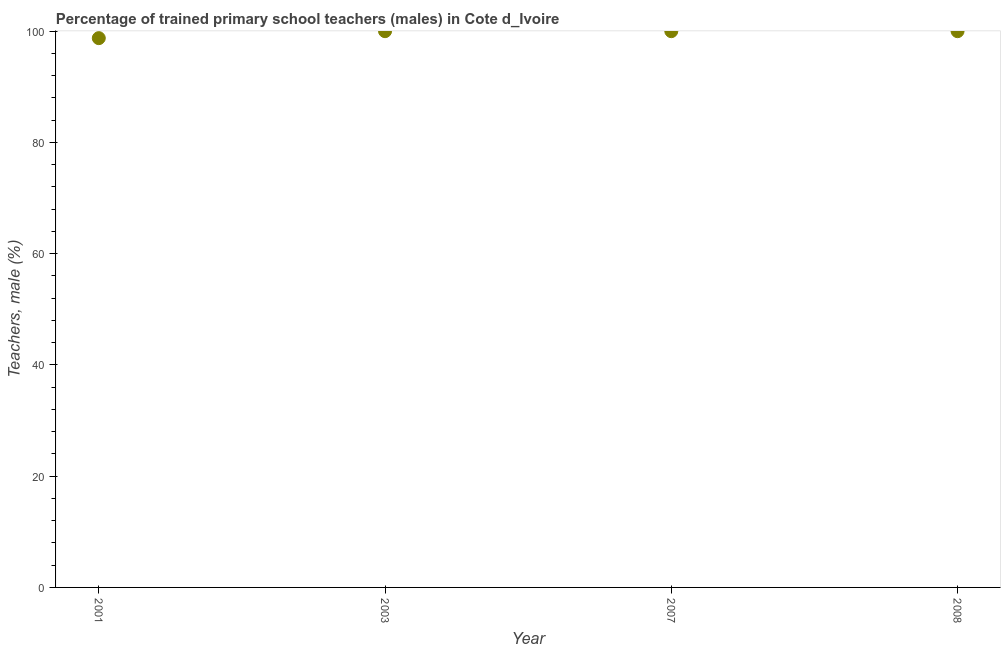What is the percentage of trained male teachers in 2008?
Offer a terse response. 100. Across all years, what is the maximum percentage of trained male teachers?
Provide a short and direct response. 100. Across all years, what is the minimum percentage of trained male teachers?
Provide a short and direct response. 98.75. In which year was the percentage of trained male teachers minimum?
Provide a succinct answer. 2001. What is the sum of the percentage of trained male teachers?
Make the answer very short. 398.75. What is the difference between the percentage of trained male teachers in 2001 and 2003?
Offer a very short reply. -1.25. What is the average percentage of trained male teachers per year?
Your answer should be very brief. 99.69. What is the median percentage of trained male teachers?
Give a very brief answer. 100. Is the percentage of trained male teachers in 2003 less than that in 2007?
Provide a succinct answer. No. Is the difference between the percentage of trained male teachers in 2001 and 2003 greater than the difference between any two years?
Your answer should be very brief. Yes. Is the sum of the percentage of trained male teachers in 2003 and 2007 greater than the maximum percentage of trained male teachers across all years?
Make the answer very short. Yes. What is the difference between the highest and the lowest percentage of trained male teachers?
Provide a short and direct response. 1.25. In how many years, is the percentage of trained male teachers greater than the average percentage of trained male teachers taken over all years?
Give a very brief answer. 3. How many dotlines are there?
Make the answer very short. 1. Are the values on the major ticks of Y-axis written in scientific E-notation?
Your answer should be compact. No. Does the graph contain any zero values?
Keep it short and to the point. No. Does the graph contain grids?
Keep it short and to the point. No. What is the title of the graph?
Offer a very short reply. Percentage of trained primary school teachers (males) in Cote d_Ivoire. What is the label or title of the X-axis?
Your answer should be very brief. Year. What is the label or title of the Y-axis?
Your answer should be compact. Teachers, male (%). What is the Teachers, male (%) in 2001?
Your answer should be compact. 98.75. What is the Teachers, male (%) in 2003?
Make the answer very short. 100. What is the difference between the Teachers, male (%) in 2001 and 2003?
Make the answer very short. -1.25. What is the difference between the Teachers, male (%) in 2001 and 2007?
Give a very brief answer. -1.25. What is the difference between the Teachers, male (%) in 2001 and 2008?
Offer a terse response. -1.25. What is the ratio of the Teachers, male (%) in 2001 to that in 2008?
Provide a short and direct response. 0.99. What is the ratio of the Teachers, male (%) in 2003 to that in 2008?
Make the answer very short. 1. What is the ratio of the Teachers, male (%) in 2007 to that in 2008?
Your response must be concise. 1. 